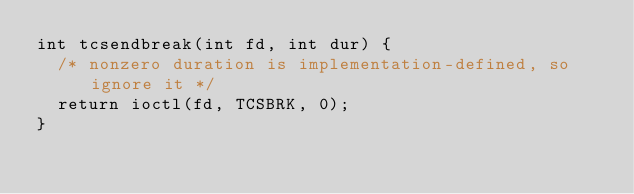<code> <loc_0><loc_0><loc_500><loc_500><_C_>int tcsendbreak(int fd, int dur) {
  /* nonzero duration is implementation-defined, so ignore it */
  return ioctl(fd, TCSBRK, 0);
}
</code> 